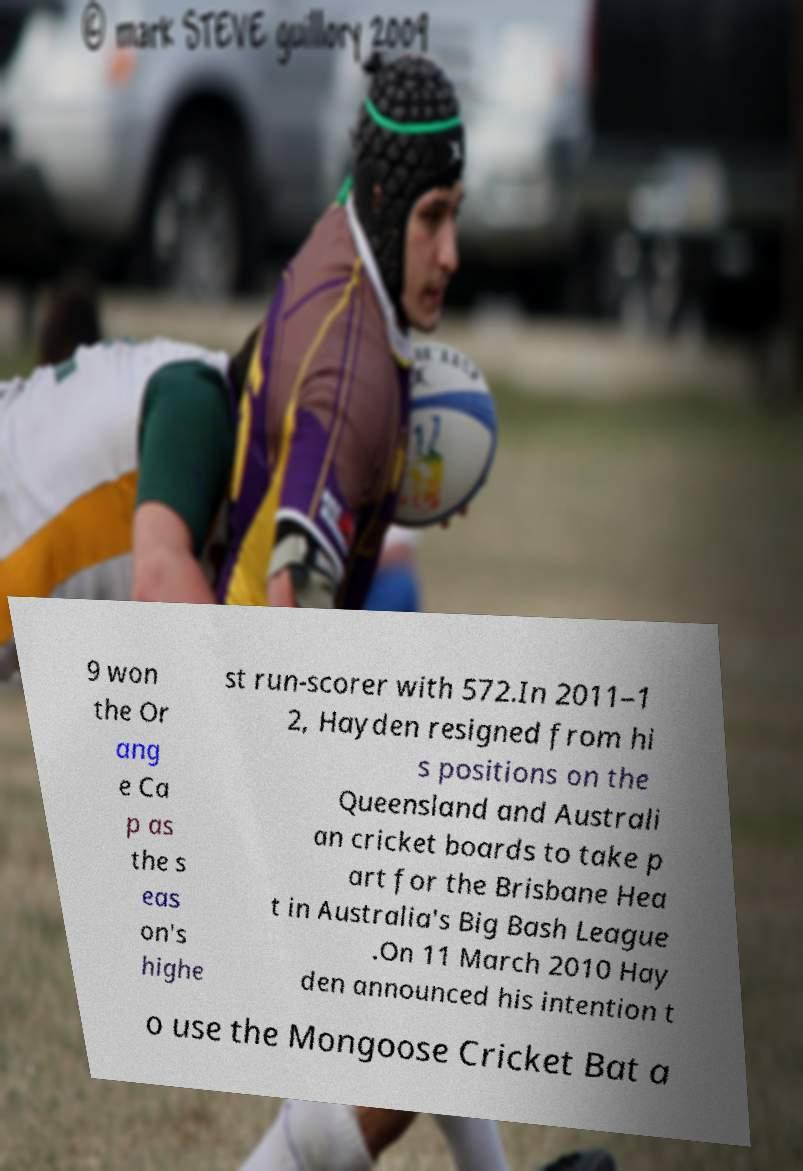For documentation purposes, I need the text within this image transcribed. Could you provide that? 9 won the Or ang e Ca p as the s eas on's highe st run-scorer with 572.In 2011–1 2, Hayden resigned from hi s positions on the Queensland and Australi an cricket boards to take p art for the Brisbane Hea t in Australia's Big Bash League .On 11 March 2010 Hay den announced his intention t o use the Mongoose Cricket Bat a 